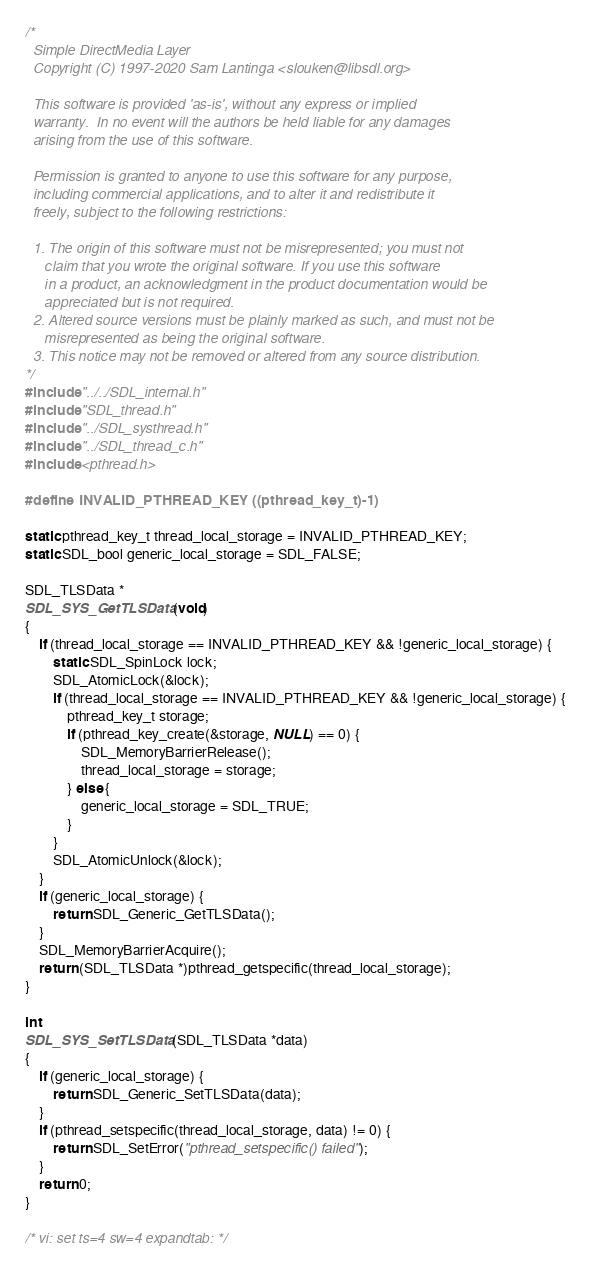<code> <loc_0><loc_0><loc_500><loc_500><_C_>/*
  Simple DirectMedia Layer
  Copyright (C) 1997-2020 Sam Lantinga <slouken@libsdl.org>

  This software is provided 'as-is', without any express or implied
  warranty.  In no event will the authors be held liable for any damages
  arising from the use of this software.

  Permission is granted to anyone to use this software for any purpose,
  including commercial applications, and to alter it and redistribute it
  freely, subject to the following restrictions:

  1. The origin of this software must not be misrepresented; you must not
     claim that you wrote the original software. If you use this software
     in a product, an acknowledgment in the product documentation would be
     appreciated but is not required.
  2. Altered source versions must be plainly marked as such, and must not be
     misrepresented as being the original software.
  3. This notice may not be removed or altered from any source distribution.
*/
#include "../../SDL_internal.h"
#include "SDL_thread.h"
#include "../SDL_systhread.h"
#include "../SDL_thread_c.h"
#include <pthread.h>

#define INVALID_PTHREAD_KEY ((pthread_key_t)-1)

static pthread_key_t thread_local_storage = INVALID_PTHREAD_KEY;
static SDL_bool generic_local_storage = SDL_FALSE;

SDL_TLSData *
SDL_SYS_GetTLSData(void)
{
    if (thread_local_storage == INVALID_PTHREAD_KEY && !generic_local_storage) {
        static SDL_SpinLock lock;
        SDL_AtomicLock(&lock);
        if (thread_local_storage == INVALID_PTHREAD_KEY && !generic_local_storage) {
            pthread_key_t storage;
            if (pthread_key_create(&storage, NULL) == 0) {
                SDL_MemoryBarrierRelease();
                thread_local_storage = storage;
            } else {
                generic_local_storage = SDL_TRUE;
            }
        }
        SDL_AtomicUnlock(&lock);
    }
    if (generic_local_storage) {
        return SDL_Generic_GetTLSData();
    }
    SDL_MemoryBarrierAcquire();
    return (SDL_TLSData *)pthread_getspecific(thread_local_storage);
}

int
SDL_SYS_SetTLSData(SDL_TLSData *data)
{
    if (generic_local_storage) {
        return SDL_Generic_SetTLSData(data);
    }
    if (pthread_setspecific(thread_local_storage, data) != 0) {
        return SDL_SetError("pthread_setspecific() failed");
    }
    return 0;
}

/* vi: set ts=4 sw=4 expandtab: */
</code> 